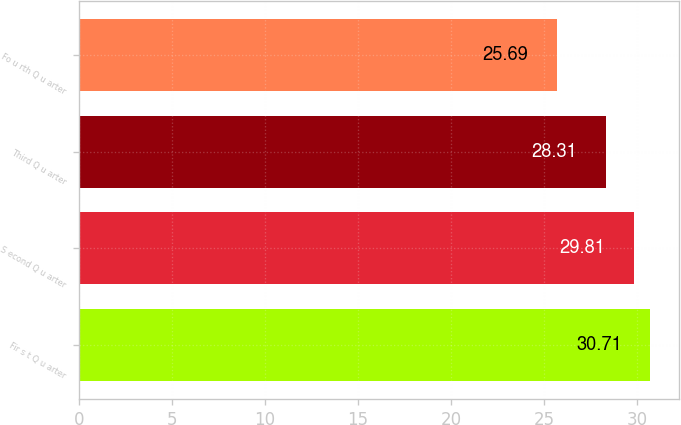Convert chart to OTSL. <chart><loc_0><loc_0><loc_500><loc_500><bar_chart><fcel>Fir s t Q u arter<fcel>S econd Q u arter<fcel>Third Q u arter<fcel>Fo u rth Q u arter<nl><fcel>30.71<fcel>29.81<fcel>28.31<fcel>25.69<nl></chart> 